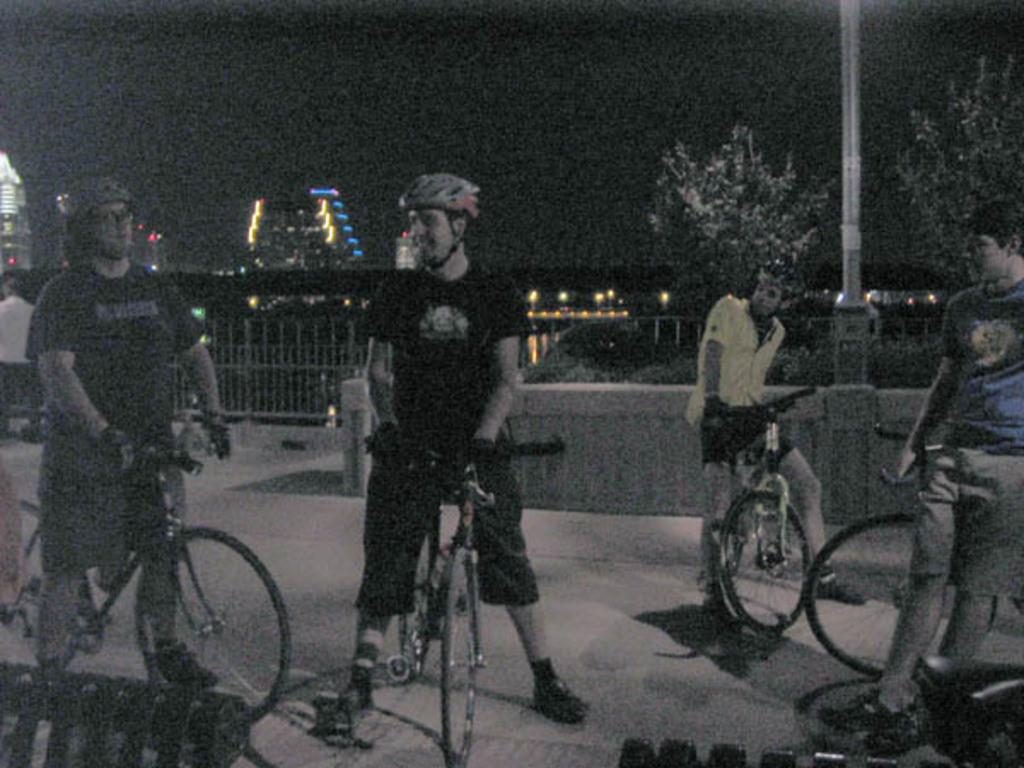How many people are in the image? There are four men in the image. What are the men doing in the image? The men are standing with their bicycles. Where are the men and their bicycles located? The men and their bicycles are on a footpath. Can you see any tigers or fairies in the image? No, there are no tigers or fairies present in the image. What is the level of friction between the bicycle tires and the footpath? The level of friction between the bicycle tires and the footpath cannot be determined from the image alone. 